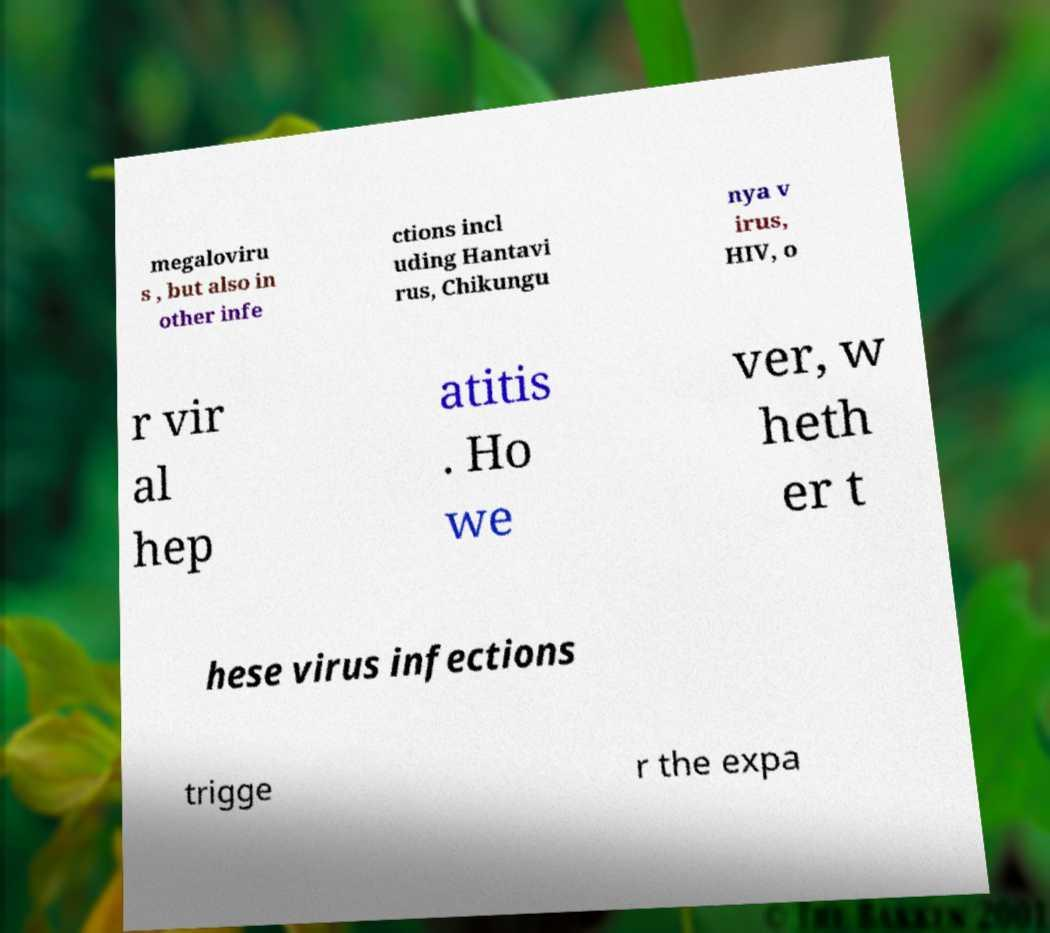Can you read and provide the text displayed in the image?This photo seems to have some interesting text. Can you extract and type it out for me? megaloviru s , but also in other infe ctions incl uding Hantavi rus, Chikungu nya v irus, HIV, o r vir al hep atitis . Ho we ver, w heth er t hese virus infections trigge r the expa 